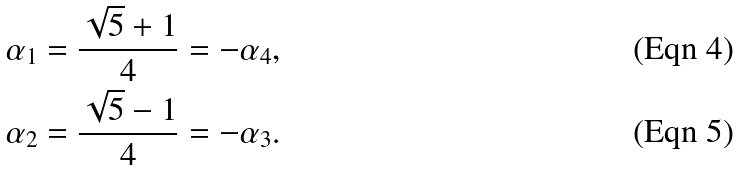<formula> <loc_0><loc_0><loc_500><loc_500>\alpha _ { 1 } & = \frac { \sqrt { 5 } + 1 } { 4 } = - \alpha _ { 4 } , \\ \alpha _ { 2 } & = \frac { \sqrt { 5 } - 1 } { 4 } = - \alpha _ { 3 } .</formula> 